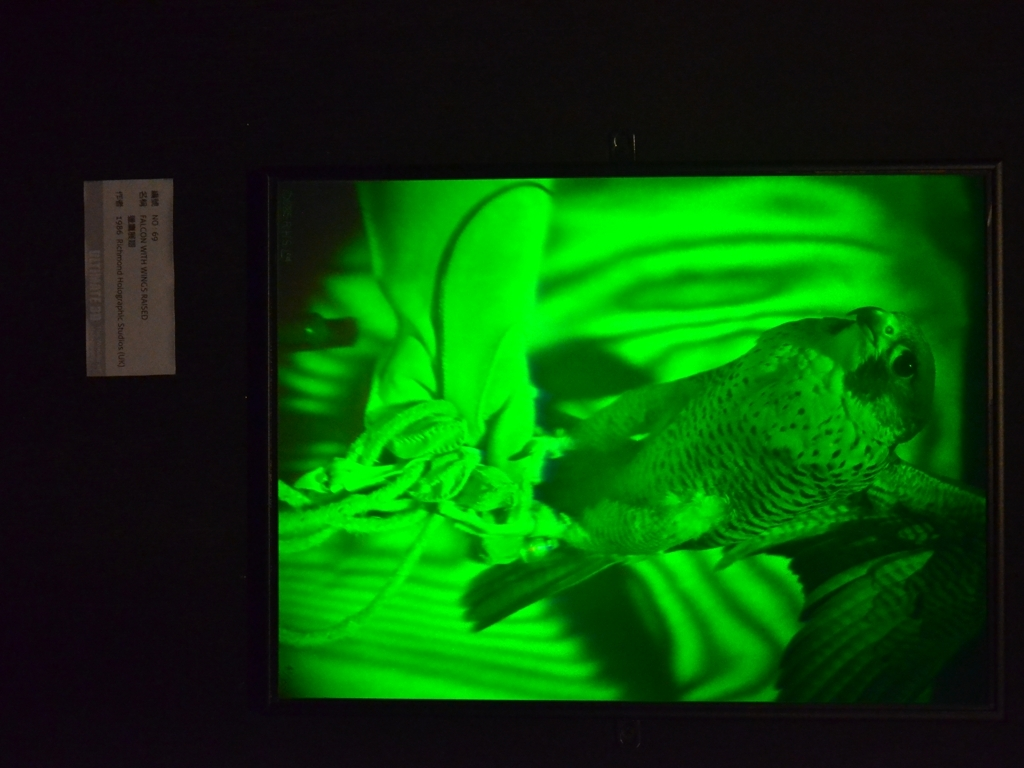Can you tell me about the composition and lighting used in this photograph? The composition of this photograph is dynamic, with the bird positioned diagonally across the frame, which creates an impression of motion and depth. The lighting used is a monochromatic green, which casts deep shadows and highlights the bird's texture and form, contributing to a sense of drama and focus on the subject. 